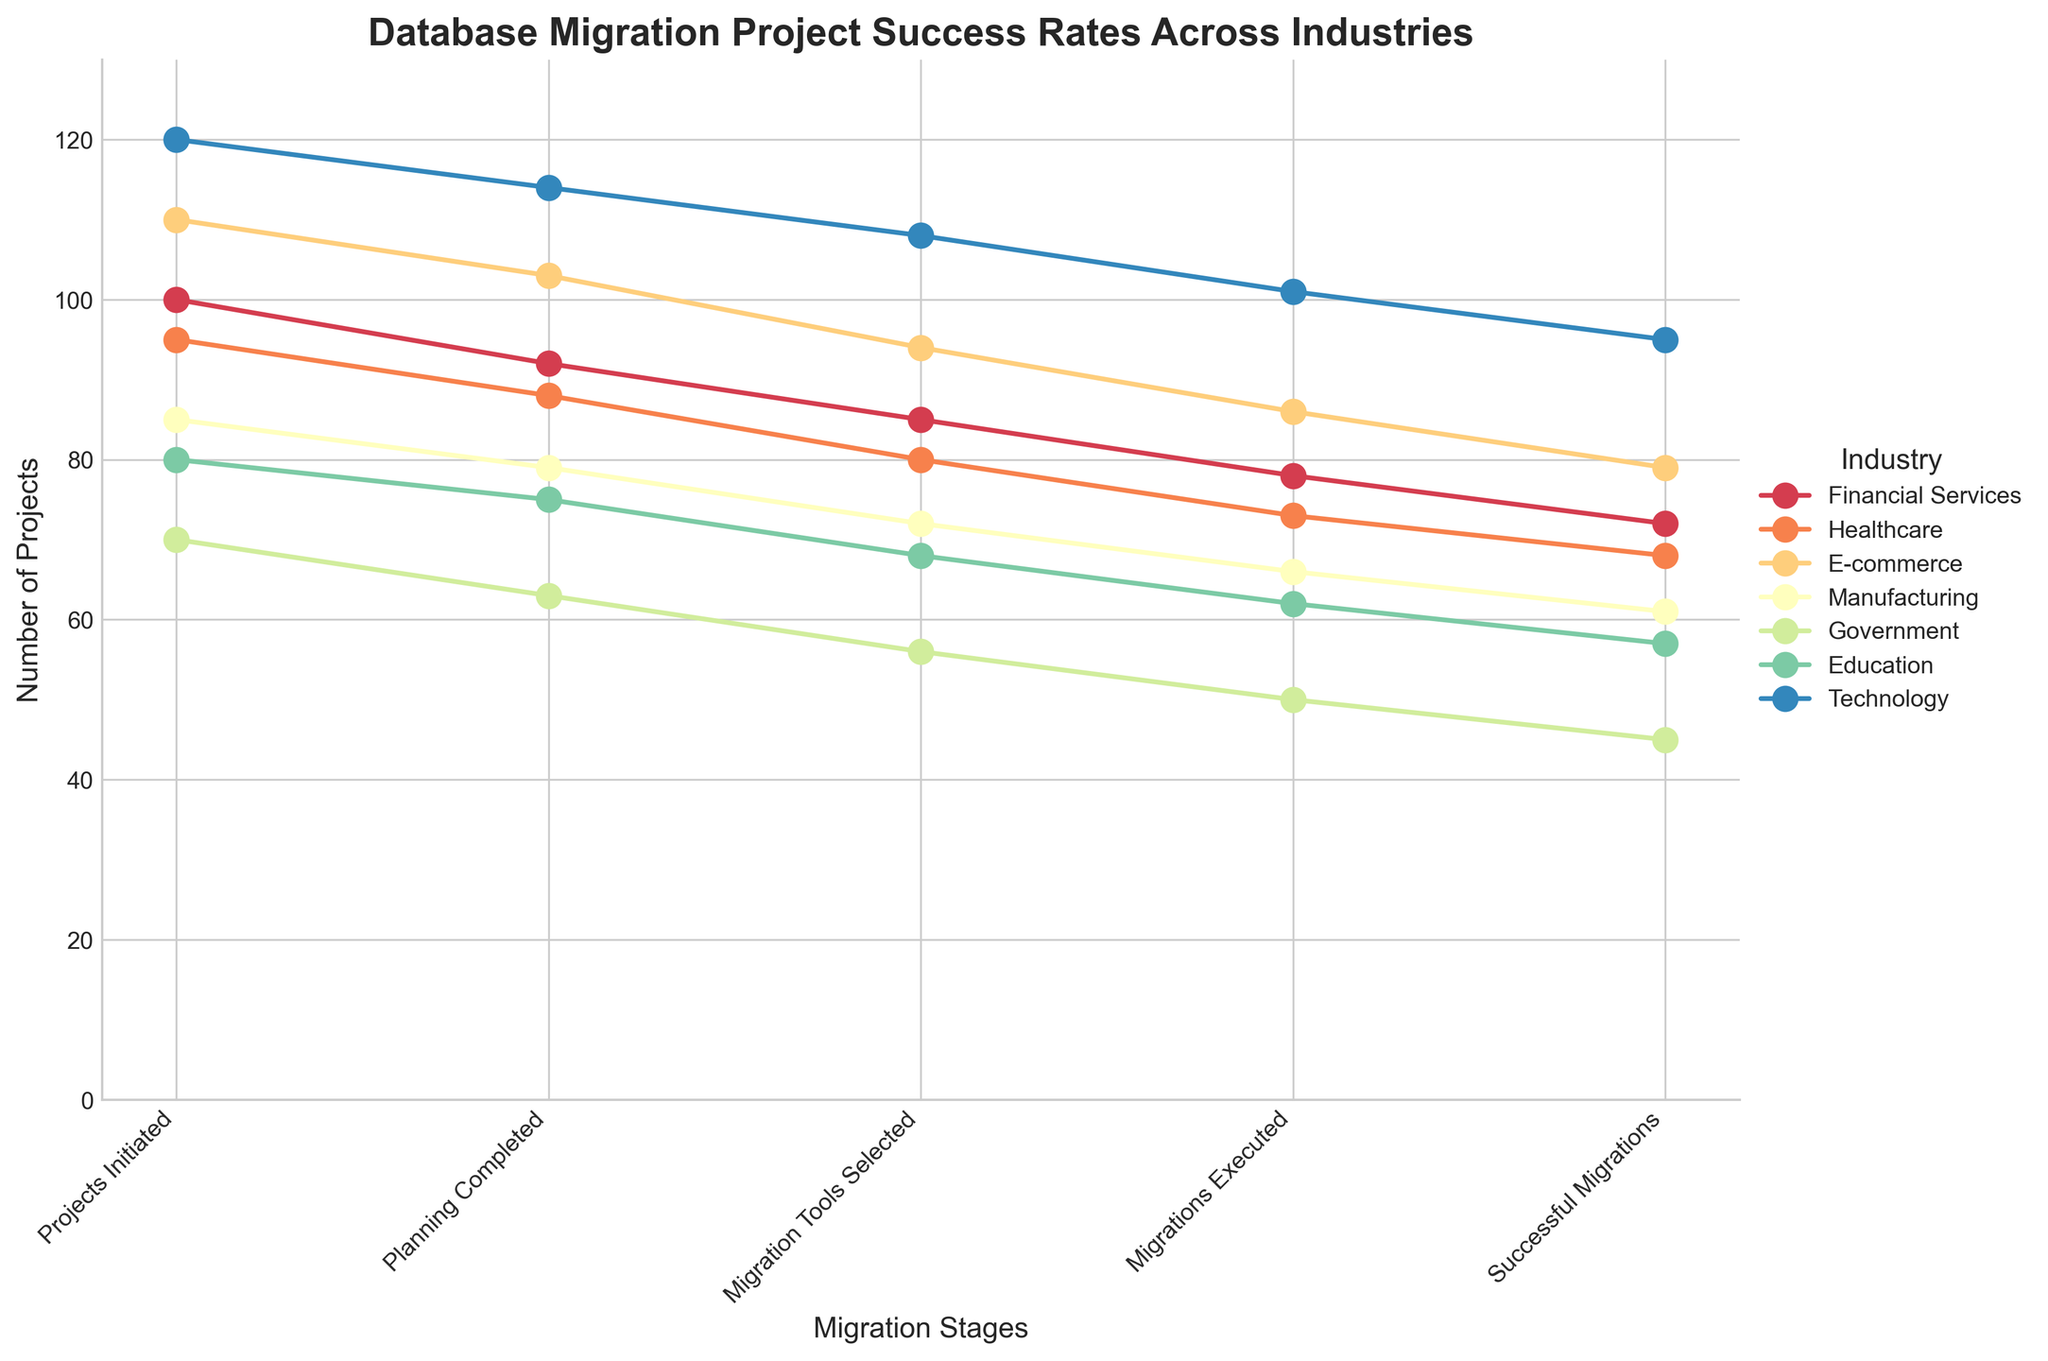What is the title of the chart? The title is usually positioned at the top of the chart. It summarizes what the chart is about in a concise manner. In this case, it is related to database migration success rates across different industries.
Answer: Database Migration Project Success Rates Across Industries What is the vertical axis labeled as? The vertical axis label is provided to indicate the measurement unit used. In this chart, it shows the number of projects at different stages.
Answer: Number of Projects Which industry initiated the most projects? By examining the "Projects Initiated" stage for each industry, identify the highest value. The Technology industry initiated 120 projects.
Answer: Technology What is the number of successful migrations in the Healthcare industry? Look at the endpoint of the line corresponding to the Healthcare industry and read the value associated with the "Successful Migrations" stage. It's 68.
Answer: 68 What are the migration stages listed along the horizontal axis? The horizontal axis represents different stages of the migration project. Read all the stages from left to right.
Answer: Projects Initiated, Planning Completed, Migration Tools Selected, Migrations Executed, Successful Migrations Which industry has the highest drop from 'Migrations Executed' to 'Successful Migrations'? Find the differences between 'Migrations Executed' and 'Successful Migrations' for each industry. The industry with the highest drop is Financial Services, dropping from 78 to 72, a difference of 6.
Answer: Financial Services How many projects did the Government sector successfully migrate? Look at the endpoint of the Government industry's line and read the value associated with 'Successful Migrations.' It's 45.
Answer: 45 Which industry had the smallest number of 'Projects Initiated'? Compare the 'Projects Initiated' values across all industries. The Government industry has the smallest number with 70.
Answer: Government Which two industries have the closest number of successful migrations? Compare the 'Successful Migrations' value for each industry and find the two closest values. Healthcare (68) and Education (57) have the smallest absolute difference of 1.
Answer: Healthcare and Education How many more successful migrations did the Technology industry have compared to the Manufacturing industry? Subtract the number of successful migrations in the Manufacturing industry from the number in the Technology industry (95 - 61).
Answer: 34 